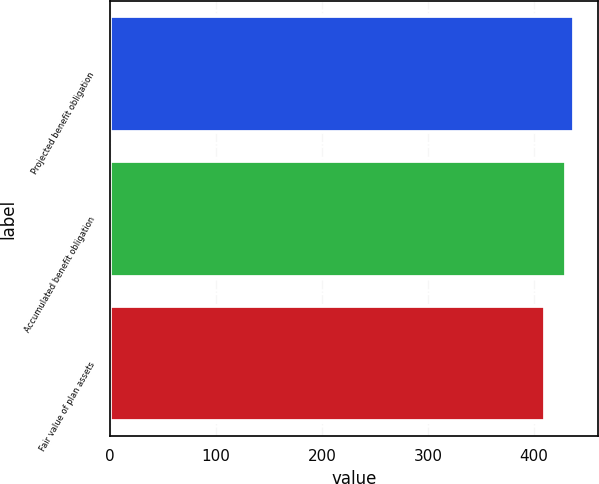Convert chart to OTSL. <chart><loc_0><loc_0><loc_500><loc_500><bar_chart><fcel>Projected benefit obligation<fcel>Accumulated benefit obligation<fcel>Fair value of plan assets<nl><fcel>438<fcel>430<fcel>410<nl></chart> 